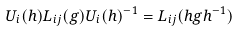Convert formula to latex. <formula><loc_0><loc_0><loc_500><loc_500>U _ { i } ( h ) L _ { i j } ( g ) U _ { i } ( h ) ^ { - 1 } = L _ { i j } ( h g h ^ { - 1 } )</formula> 